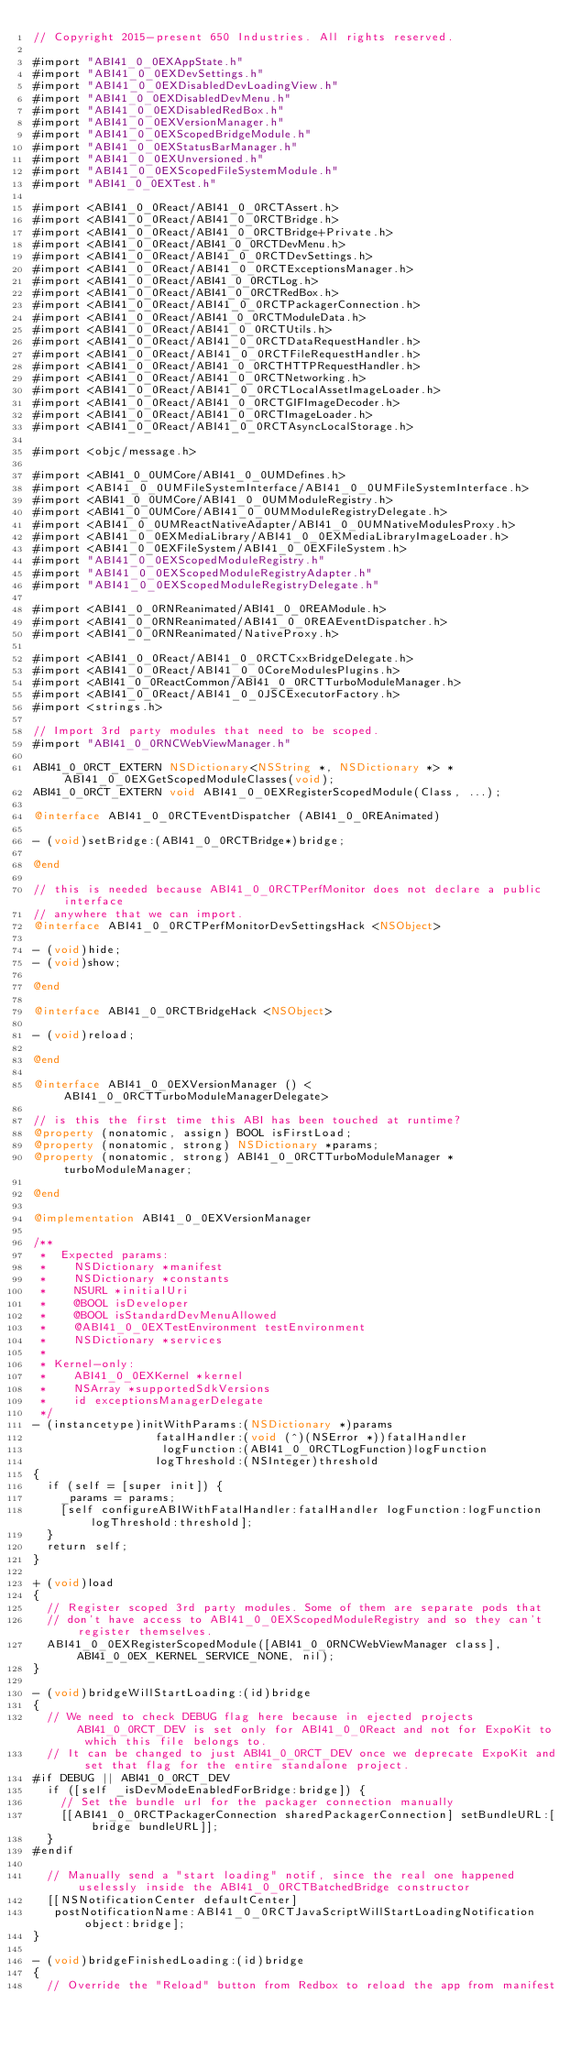Convert code to text. <code><loc_0><loc_0><loc_500><loc_500><_ObjectiveC_>// Copyright 2015-present 650 Industries. All rights reserved.

#import "ABI41_0_0EXAppState.h"
#import "ABI41_0_0EXDevSettings.h"
#import "ABI41_0_0EXDisabledDevLoadingView.h"
#import "ABI41_0_0EXDisabledDevMenu.h"
#import "ABI41_0_0EXDisabledRedBox.h"
#import "ABI41_0_0EXVersionManager.h"
#import "ABI41_0_0EXScopedBridgeModule.h"
#import "ABI41_0_0EXStatusBarManager.h"
#import "ABI41_0_0EXUnversioned.h"
#import "ABI41_0_0EXScopedFileSystemModule.h"
#import "ABI41_0_0EXTest.h"

#import <ABI41_0_0React/ABI41_0_0RCTAssert.h>
#import <ABI41_0_0React/ABI41_0_0RCTBridge.h>
#import <ABI41_0_0React/ABI41_0_0RCTBridge+Private.h>
#import <ABI41_0_0React/ABI41_0_0RCTDevMenu.h>
#import <ABI41_0_0React/ABI41_0_0RCTDevSettings.h>
#import <ABI41_0_0React/ABI41_0_0RCTExceptionsManager.h>
#import <ABI41_0_0React/ABI41_0_0RCTLog.h>
#import <ABI41_0_0React/ABI41_0_0RCTRedBox.h>
#import <ABI41_0_0React/ABI41_0_0RCTPackagerConnection.h>
#import <ABI41_0_0React/ABI41_0_0RCTModuleData.h>
#import <ABI41_0_0React/ABI41_0_0RCTUtils.h>
#import <ABI41_0_0React/ABI41_0_0RCTDataRequestHandler.h>
#import <ABI41_0_0React/ABI41_0_0RCTFileRequestHandler.h>
#import <ABI41_0_0React/ABI41_0_0RCTHTTPRequestHandler.h>
#import <ABI41_0_0React/ABI41_0_0RCTNetworking.h>
#import <ABI41_0_0React/ABI41_0_0RCTLocalAssetImageLoader.h>
#import <ABI41_0_0React/ABI41_0_0RCTGIFImageDecoder.h>
#import <ABI41_0_0React/ABI41_0_0RCTImageLoader.h>
#import <ABI41_0_0React/ABI41_0_0RCTAsyncLocalStorage.h>

#import <objc/message.h>

#import <ABI41_0_0UMCore/ABI41_0_0UMDefines.h>
#import <ABI41_0_0UMFileSystemInterface/ABI41_0_0UMFileSystemInterface.h>
#import <ABI41_0_0UMCore/ABI41_0_0UMModuleRegistry.h>
#import <ABI41_0_0UMCore/ABI41_0_0UMModuleRegistryDelegate.h>
#import <ABI41_0_0UMReactNativeAdapter/ABI41_0_0UMNativeModulesProxy.h>
#import <ABI41_0_0EXMediaLibrary/ABI41_0_0EXMediaLibraryImageLoader.h>
#import <ABI41_0_0EXFileSystem/ABI41_0_0EXFileSystem.h>
#import "ABI41_0_0EXScopedModuleRegistry.h"
#import "ABI41_0_0EXScopedModuleRegistryAdapter.h"
#import "ABI41_0_0EXScopedModuleRegistryDelegate.h"

#import <ABI41_0_0RNReanimated/ABI41_0_0REAModule.h>
#import <ABI41_0_0RNReanimated/ABI41_0_0REAEventDispatcher.h>
#import <ABI41_0_0RNReanimated/NativeProxy.h>

#import <ABI41_0_0React/ABI41_0_0RCTCxxBridgeDelegate.h>
#import <ABI41_0_0React/ABI41_0_0CoreModulesPlugins.h>
#import <ABI41_0_0ReactCommon/ABI41_0_0RCTTurboModuleManager.h>
#import <ABI41_0_0React/ABI41_0_0JSCExecutorFactory.h>
#import <strings.h>

// Import 3rd party modules that need to be scoped.
#import "ABI41_0_0RNCWebViewManager.h"

ABI41_0_0RCT_EXTERN NSDictionary<NSString *, NSDictionary *> *ABI41_0_0EXGetScopedModuleClasses(void);
ABI41_0_0RCT_EXTERN void ABI41_0_0EXRegisterScopedModule(Class, ...);

@interface ABI41_0_0RCTEventDispatcher (ABI41_0_0REAnimated)

- (void)setBridge:(ABI41_0_0RCTBridge*)bridge;

@end

// this is needed because ABI41_0_0RCTPerfMonitor does not declare a public interface
// anywhere that we can import.
@interface ABI41_0_0RCTPerfMonitorDevSettingsHack <NSObject>

- (void)hide;
- (void)show;

@end

@interface ABI41_0_0RCTBridgeHack <NSObject>

- (void)reload;

@end

@interface ABI41_0_0EXVersionManager () <ABI41_0_0RCTTurboModuleManagerDelegate>

// is this the first time this ABI has been touched at runtime?
@property (nonatomic, assign) BOOL isFirstLoad;
@property (nonatomic, strong) NSDictionary *params;
@property (nonatomic, strong) ABI41_0_0RCTTurboModuleManager *turboModuleManager;

@end

@implementation ABI41_0_0EXVersionManager

/**
 *  Expected params:
 *    NSDictionary *manifest
 *    NSDictionary *constants
 *    NSURL *initialUri
 *    @BOOL isDeveloper
 *    @BOOL isStandardDevMenuAllowed
 *    @ABI41_0_0EXTestEnvironment testEnvironment
 *    NSDictionary *services
 *
 * Kernel-only:
 *    ABI41_0_0EXKernel *kernel
 *    NSArray *supportedSdkVersions
 *    id exceptionsManagerDelegate
 */
- (instancetype)initWithParams:(NSDictionary *)params
                  fatalHandler:(void (^)(NSError *))fatalHandler
                   logFunction:(ABI41_0_0RCTLogFunction)logFunction
                  logThreshold:(NSInteger)threshold
{
  if (self = [super init]) {
    _params = params;
    [self configureABIWithFatalHandler:fatalHandler logFunction:logFunction logThreshold:threshold];
  }
  return self;
}

+ (void)load
{
  // Register scoped 3rd party modules. Some of them are separate pods that
  // don't have access to ABI41_0_0EXScopedModuleRegistry and so they can't register themselves.
  ABI41_0_0EXRegisterScopedModule([ABI41_0_0RNCWebViewManager class], ABI41_0_0EX_KERNEL_SERVICE_NONE, nil);
}

- (void)bridgeWillStartLoading:(id)bridge
{
  // We need to check DEBUG flag here because in ejected projects ABI41_0_0RCT_DEV is set only for ABI41_0_0React and not for ExpoKit to which this file belongs to.
  // It can be changed to just ABI41_0_0RCT_DEV once we deprecate ExpoKit and set that flag for the entire standalone project.
#if DEBUG || ABI41_0_0RCT_DEV
  if ([self _isDevModeEnabledForBridge:bridge]) {
    // Set the bundle url for the packager connection manually
    [[ABI41_0_0RCTPackagerConnection sharedPackagerConnection] setBundleURL:[bridge bundleURL]];
  }
#endif

  // Manually send a "start loading" notif, since the real one happened uselessly inside the ABI41_0_0RCTBatchedBridge constructor
  [[NSNotificationCenter defaultCenter]
   postNotificationName:ABI41_0_0RCTJavaScriptWillStartLoadingNotification object:bridge];
}

- (void)bridgeFinishedLoading:(id)bridge
{
  // Override the "Reload" button from Redbox to reload the app from manifest</code> 